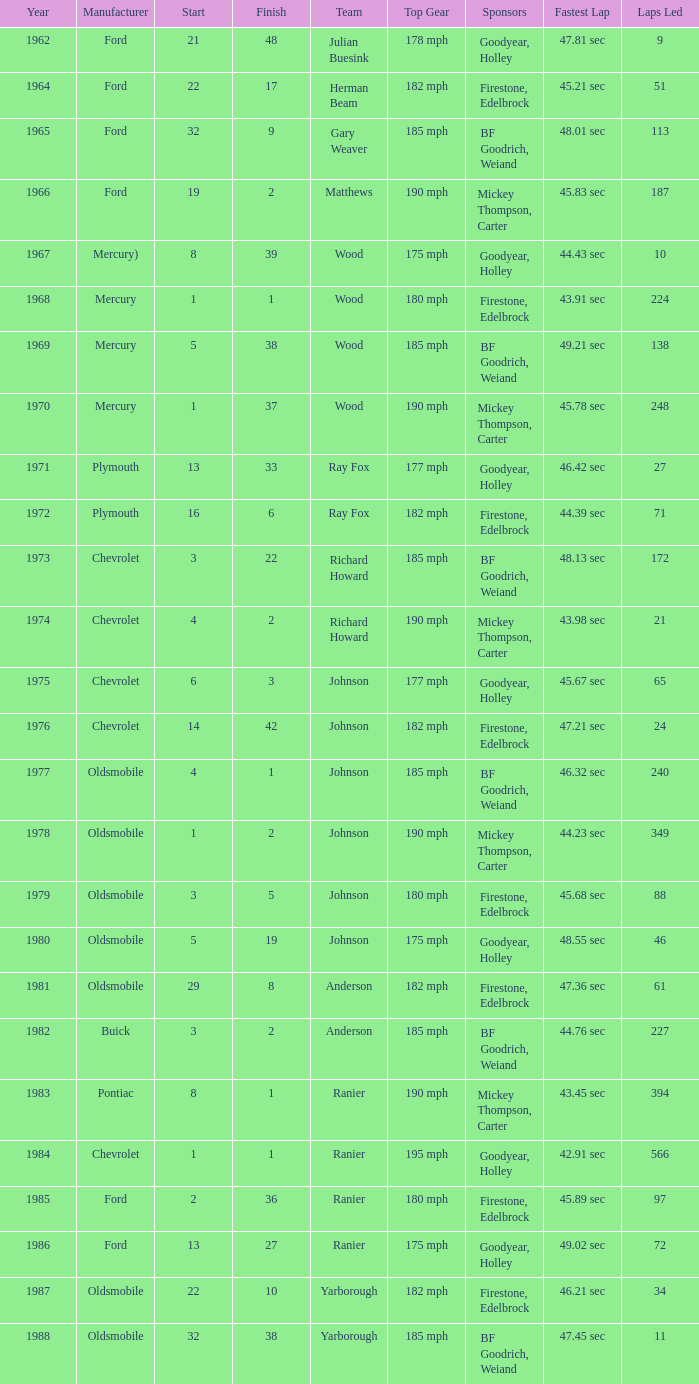Who was the maufacturer of the vehicle during the race where Cale Yarborough started at 19 and finished earlier than 42? Ford. 